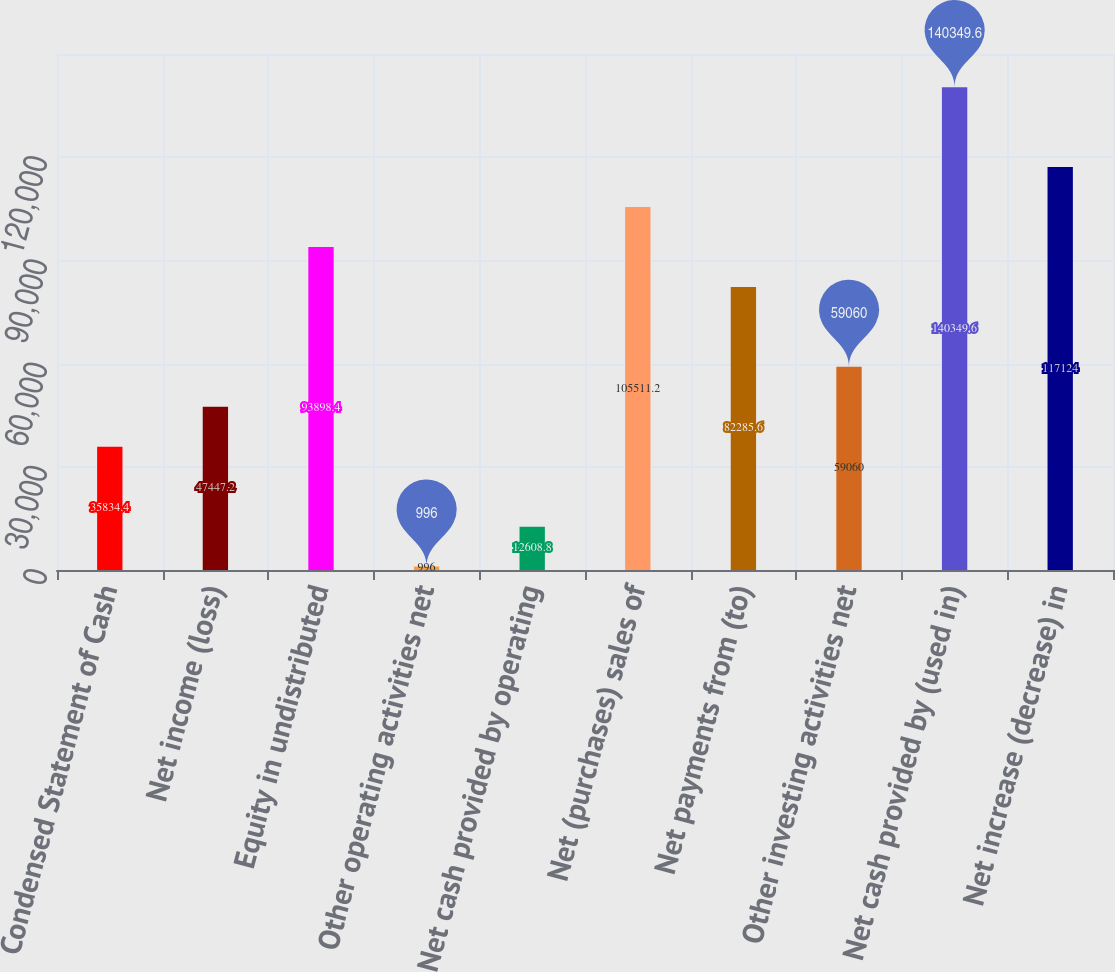Convert chart. <chart><loc_0><loc_0><loc_500><loc_500><bar_chart><fcel>Condensed Statement of Cash<fcel>Net income (loss)<fcel>Equity in undistributed<fcel>Other operating activities net<fcel>Net cash provided by operating<fcel>Net (purchases) sales of<fcel>Net payments from (to)<fcel>Other investing activities net<fcel>Net cash provided by (used in)<fcel>Net increase (decrease) in<nl><fcel>35834.4<fcel>47447.2<fcel>93898.4<fcel>996<fcel>12608.8<fcel>105511<fcel>82285.6<fcel>59060<fcel>140350<fcel>117124<nl></chart> 